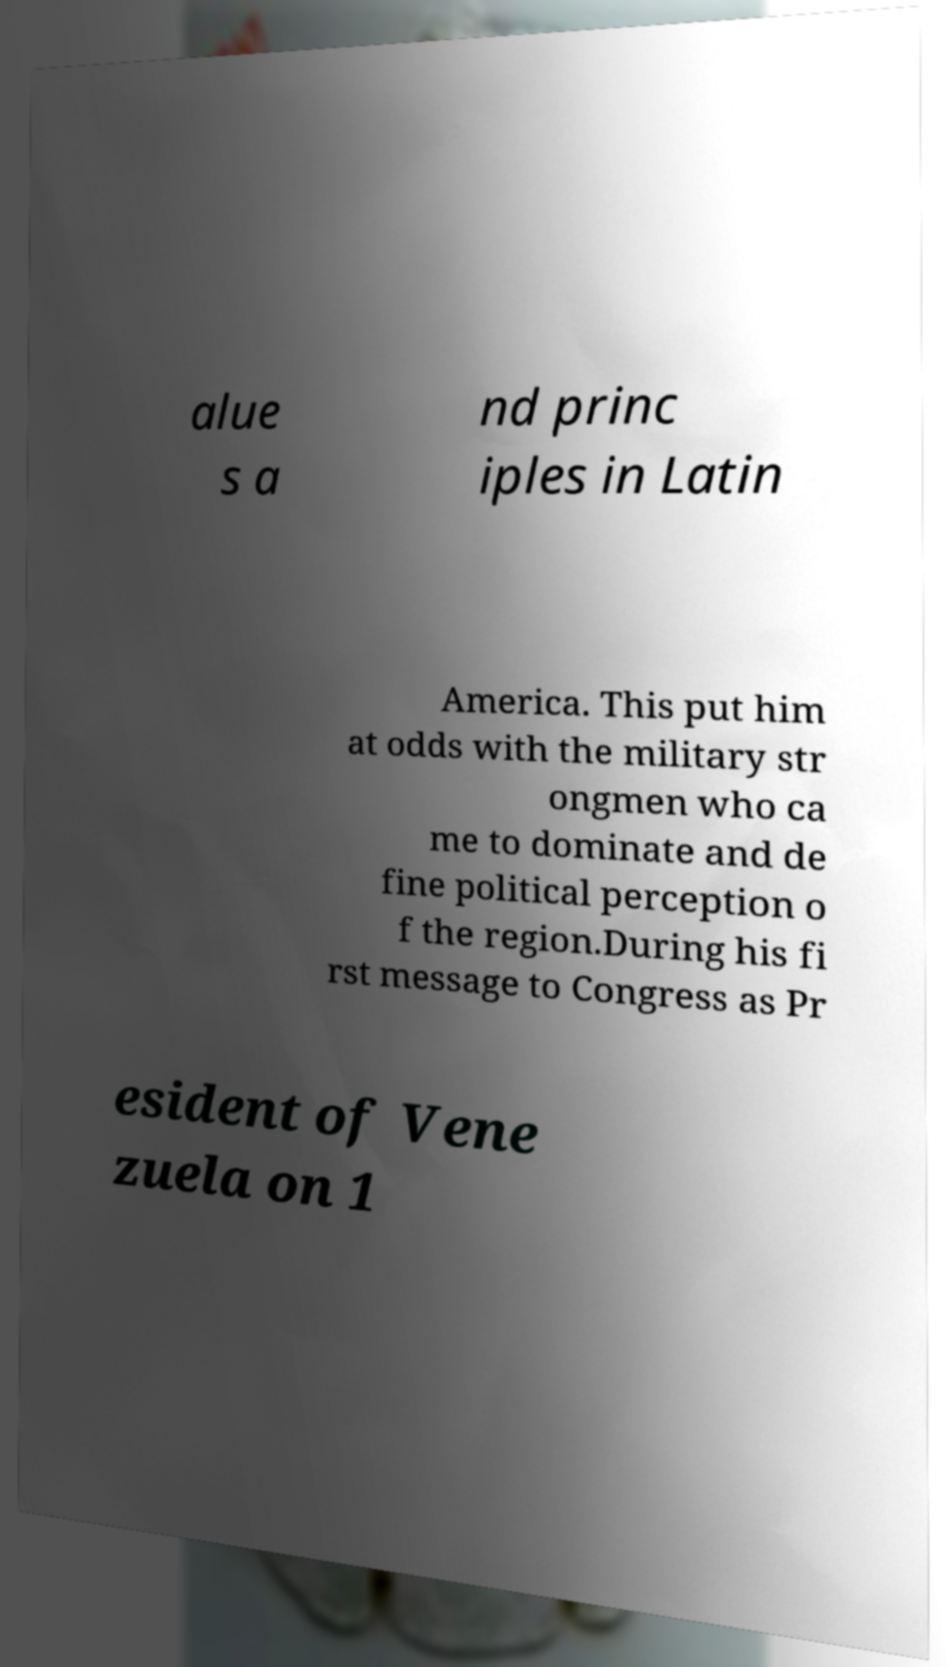What messages or text are displayed in this image? I need them in a readable, typed format. alue s a nd princ iples in Latin America. This put him at odds with the military str ongmen who ca me to dominate and de fine political perception o f the region.During his fi rst message to Congress as Pr esident of Vene zuela on 1 